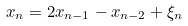Convert formula to latex. <formula><loc_0><loc_0><loc_500><loc_500>x _ { n } = 2 x _ { n - 1 } - x _ { n - 2 } + \xi _ { n }</formula> 